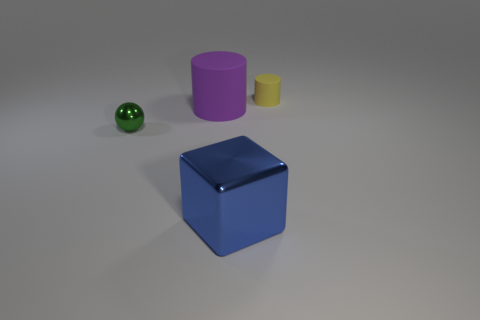Subtract all blocks. Subtract all blocks. How many objects are left? 2 Add 3 blue things. How many blue things are left? 4 Add 4 big brown shiny cylinders. How many big brown shiny cylinders exist? 4 Add 2 big matte things. How many objects exist? 6 Subtract 1 blue blocks. How many objects are left? 3 Subtract all spheres. How many objects are left? 3 Subtract 1 cylinders. How many cylinders are left? 1 Subtract all blue cylinders. Subtract all purple cubes. How many cylinders are left? 2 Subtract all yellow cylinders. How many yellow balls are left? 0 